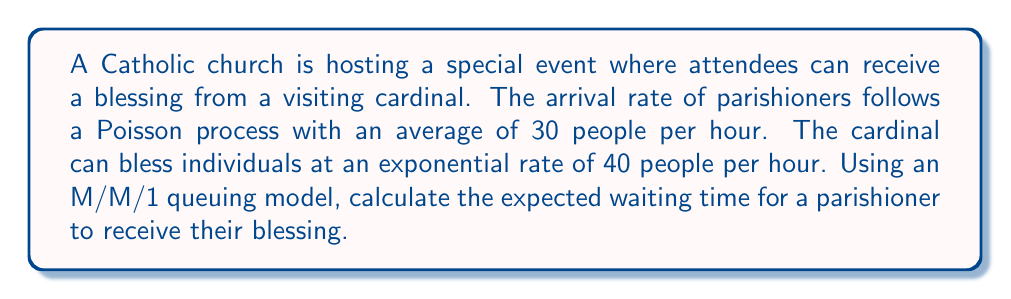What is the answer to this math problem? To solve this problem, we'll use the M/M/1 queuing model, where:

1. $\lambda$ = arrival rate = 30 people/hour
2. $\mu$ = service rate = 40 people/hour

Step 1: Calculate the utilization factor $\rho$
$$\rho = \frac{\lambda}{\mu} = \frac{30}{40} = 0.75$$

Step 2: Calculate the expected number of people in the system (L)
$$L = \frac{\rho}{1-\rho} = \frac{0.75}{1-0.75} = 3$$

Step 3: Calculate the expected waiting time in the system (W) using Little's Law
$$W = \frac{L}{\lambda} = \frac{3}{30} = 0.1 \text{ hours}$$

Step 4: Convert the waiting time to minutes
$$W = 0.1 \text{ hours} \times 60 \text{ minutes/hour} = 6 \text{ minutes}$$

Therefore, the expected waiting time for a parishioner to receive their blessing is 6 minutes.
Answer: 6 minutes 